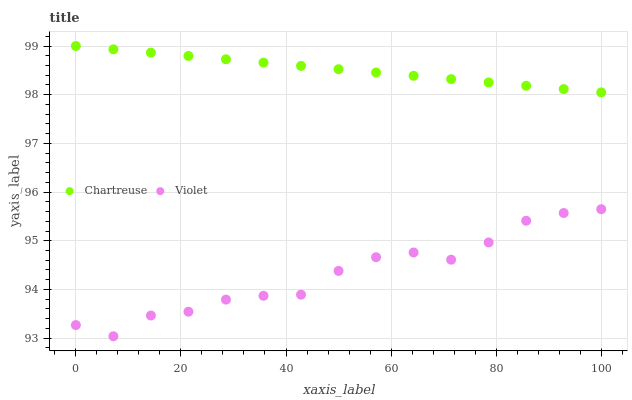Does Violet have the minimum area under the curve?
Answer yes or no. Yes. Does Chartreuse have the maximum area under the curve?
Answer yes or no. Yes. Does Violet have the maximum area under the curve?
Answer yes or no. No. Is Chartreuse the smoothest?
Answer yes or no. Yes. Is Violet the roughest?
Answer yes or no. Yes. Is Violet the smoothest?
Answer yes or no. No. Does Violet have the lowest value?
Answer yes or no. Yes. Does Chartreuse have the highest value?
Answer yes or no. Yes. Does Violet have the highest value?
Answer yes or no. No. Is Violet less than Chartreuse?
Answer yes or no. Yes. Is Chartreuse greater than Violet?
Answer yes or no. Yes. Does Violet intersect Chartreuse?
Answer yes or no. No. 